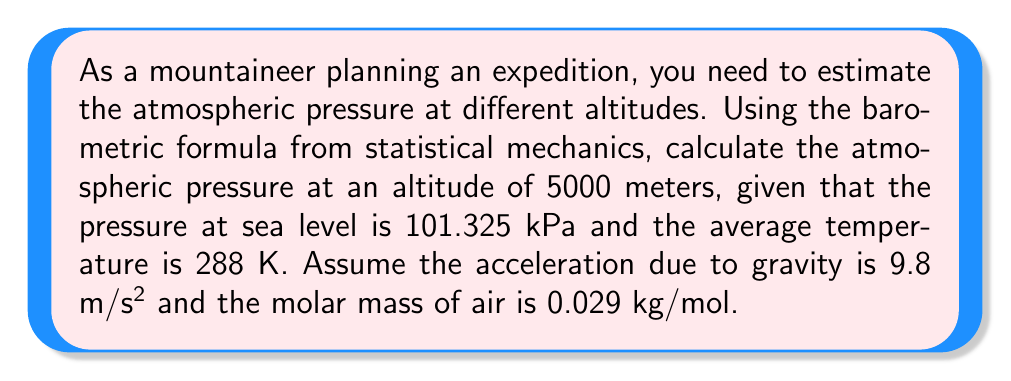Provide a solution to this math problem. To solve this problem, we'll use the barometric formula derived from statistical mechanics:

$$P = P_0 e^{-\frac{mgh}{k_BT}}$$

Where:
$P$ = Pressure at altitude h
$P_0$ = Pressure at sea level (101.325 kPa)
$m$ = Molar mass of air (0.029 kg/mol)
$g$ = Acceleration due to gravity (9.8 m/s²)
$h$ = Altitude (5000 m)
$k_B$ = Boltzmann constant (1.380649 × 10^-23 J/K)
$T$ = Average temperature (288 K)

Step 1: Convert the molar mass to mass per molecule:
$m_{molecule} = \frac{0.029 \text{ kg/mol}}{6.022 \times 10^{23} \text{ molecules/mol}} = 4.81 \times 10^{-26} \text{ kg}$

Step 2: Calculate the exponent:
$$\frac{mgh}{k_BT} = \frac{(4.81 \times 10^{-26})(9.8)(5000)}{(1.380649 \times 10^{-23})(288)} = 0.5726$$

Step 3: Calculate the pressure at 5000 m:
$$P = 101325 \text{ Pa} \times e^{-0.5726} = 56,544 \text{ Pa} = 56.54 \text{ kPa}$$
Answer: 56.54 kPa 